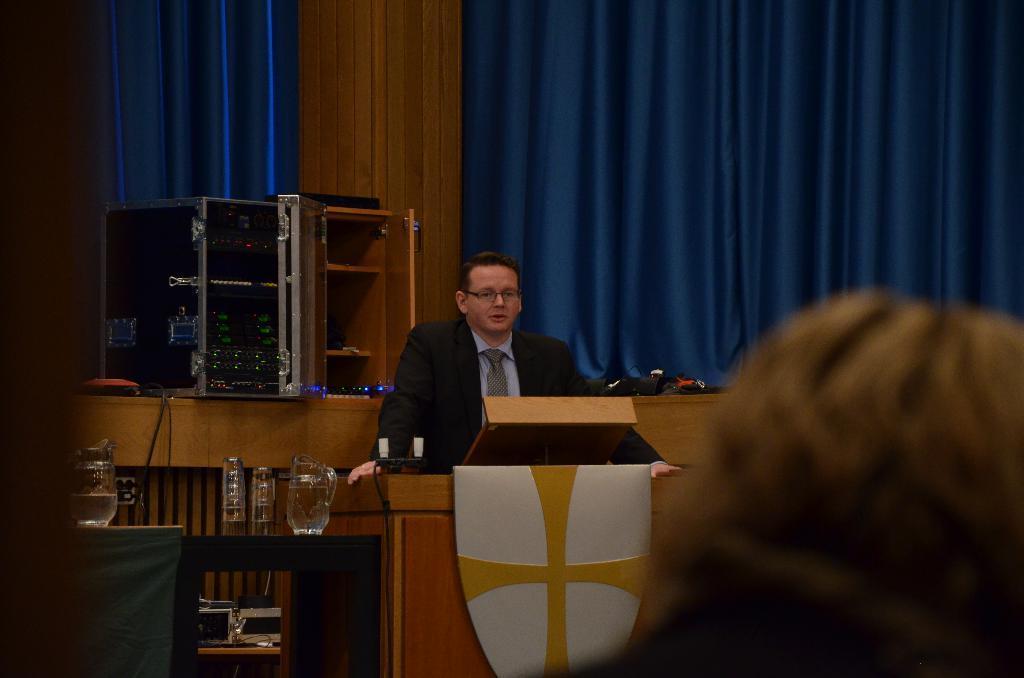Could you give a brief overview of what you see in this image? In this image we can see a man is standing. He is wearing coat with blue shirt and tie. In front of him podium is there. On podium mics are there. Behind him blue color curtains are there and one rectangular box is present. Bottom of the image one table is there. On table glasses and jugs are present. Right bottom of the image one person is there. 